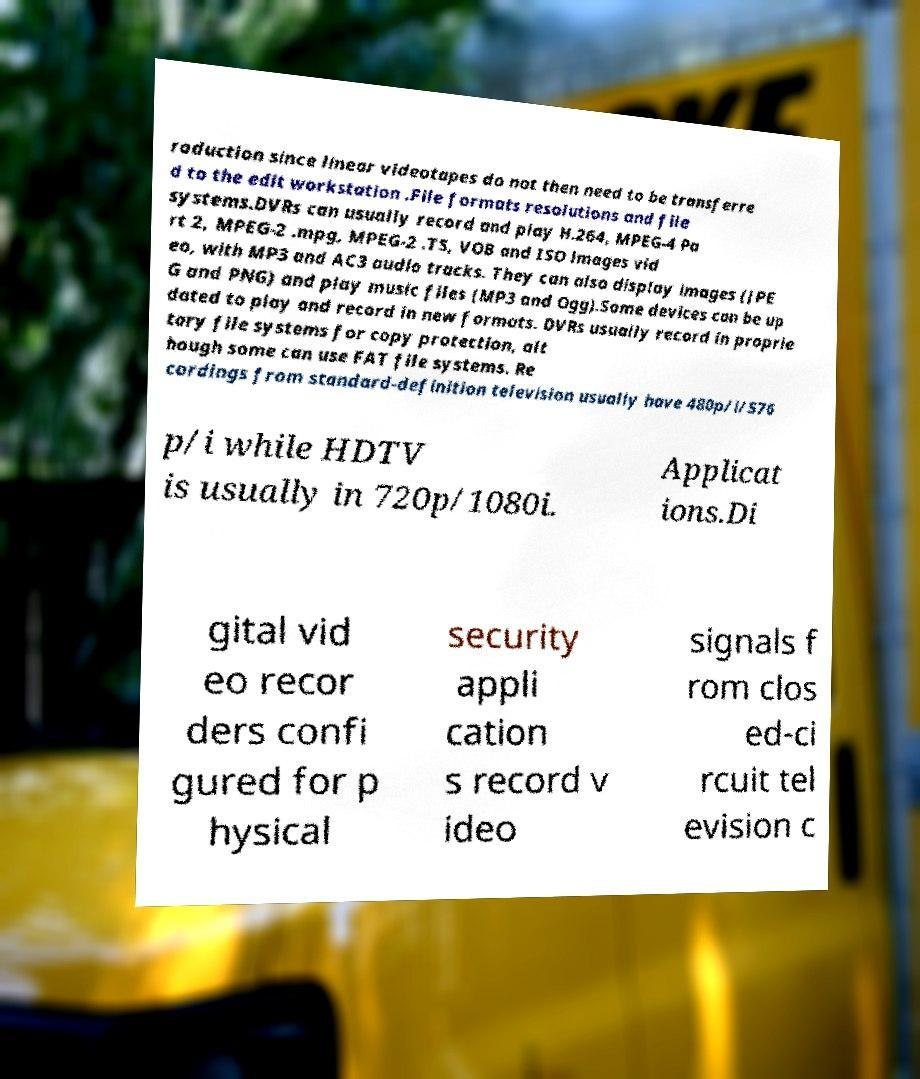Please identify and transcribe the text found in this image. roduction since linear videotapes do not then need to be transferre d to the edit workstation .File formats resolutions and file systems.DVRs can usually record and play H.264, MPEG-4 Pa rt 2, MPEG-2 .mpg, MPEG-2 .TS, VOB and ISO images vid eo, with MP3 and AC3 audio tracks. They can also display images (JPE G and PNG) and play music files (MP3 and Ogg).Some devices can be up dated to play and record in new formats. DVRs usually record in proprie tary file systems for copy protection, alt hough some can use FAT file systems. Re cordings from standard-definition television usually have 480p/i/576 p/i while HDTV is usually in 720p/1080i. Applicat ions.Di gital vid eo recor ders confi gured for p hysical security appli cation s record v ideo signals f rom clos ed-ci rcuit tel evision c 